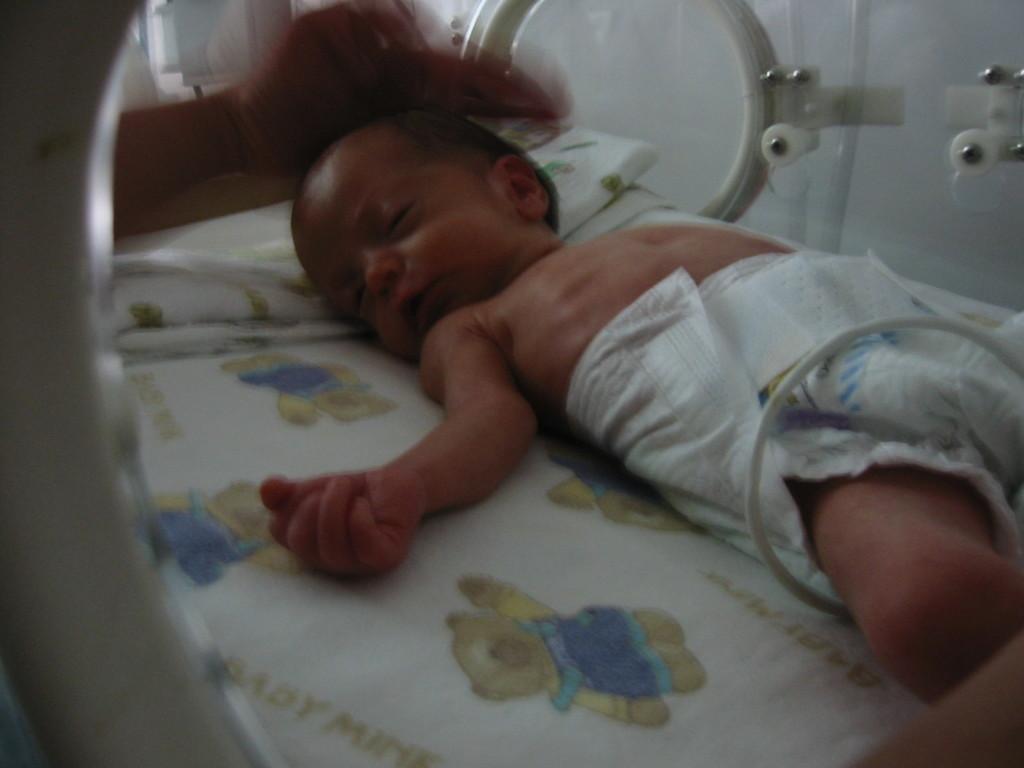How would you summarize this image in a sentence or two? In this image I can see a baby wearing white colored dress is laying on the bed which is white, blue and yellow in color. I can see a persons hand which is blurry and few white colored surfaces in the background. 